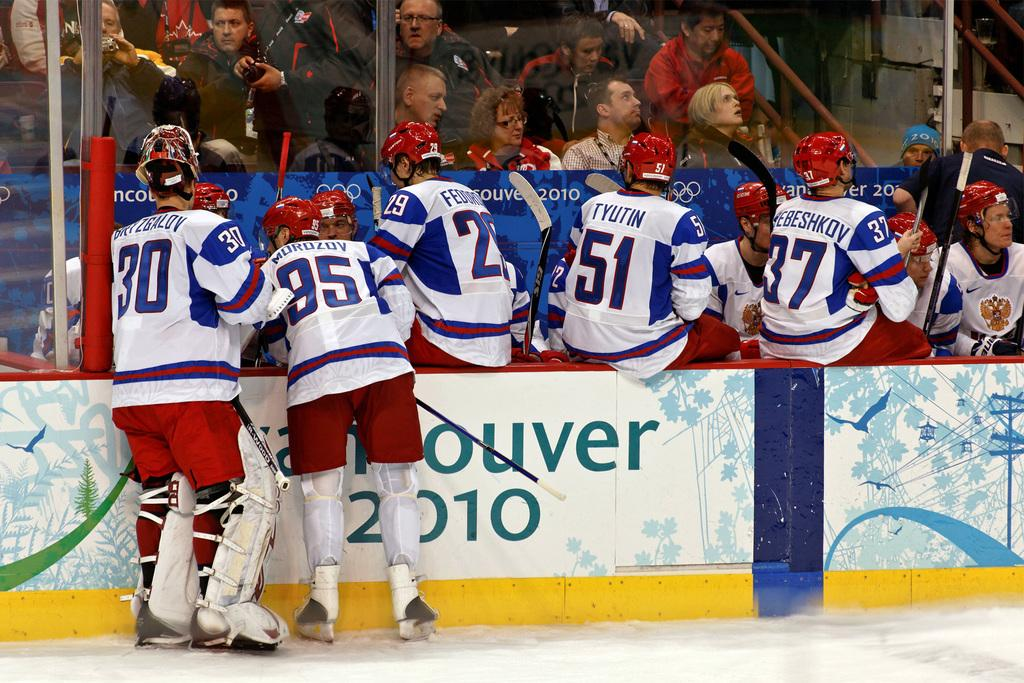<image>
Render a clear and concise summary of the photo. An ice hockey team is by the benches in Vancouver in 2010. 